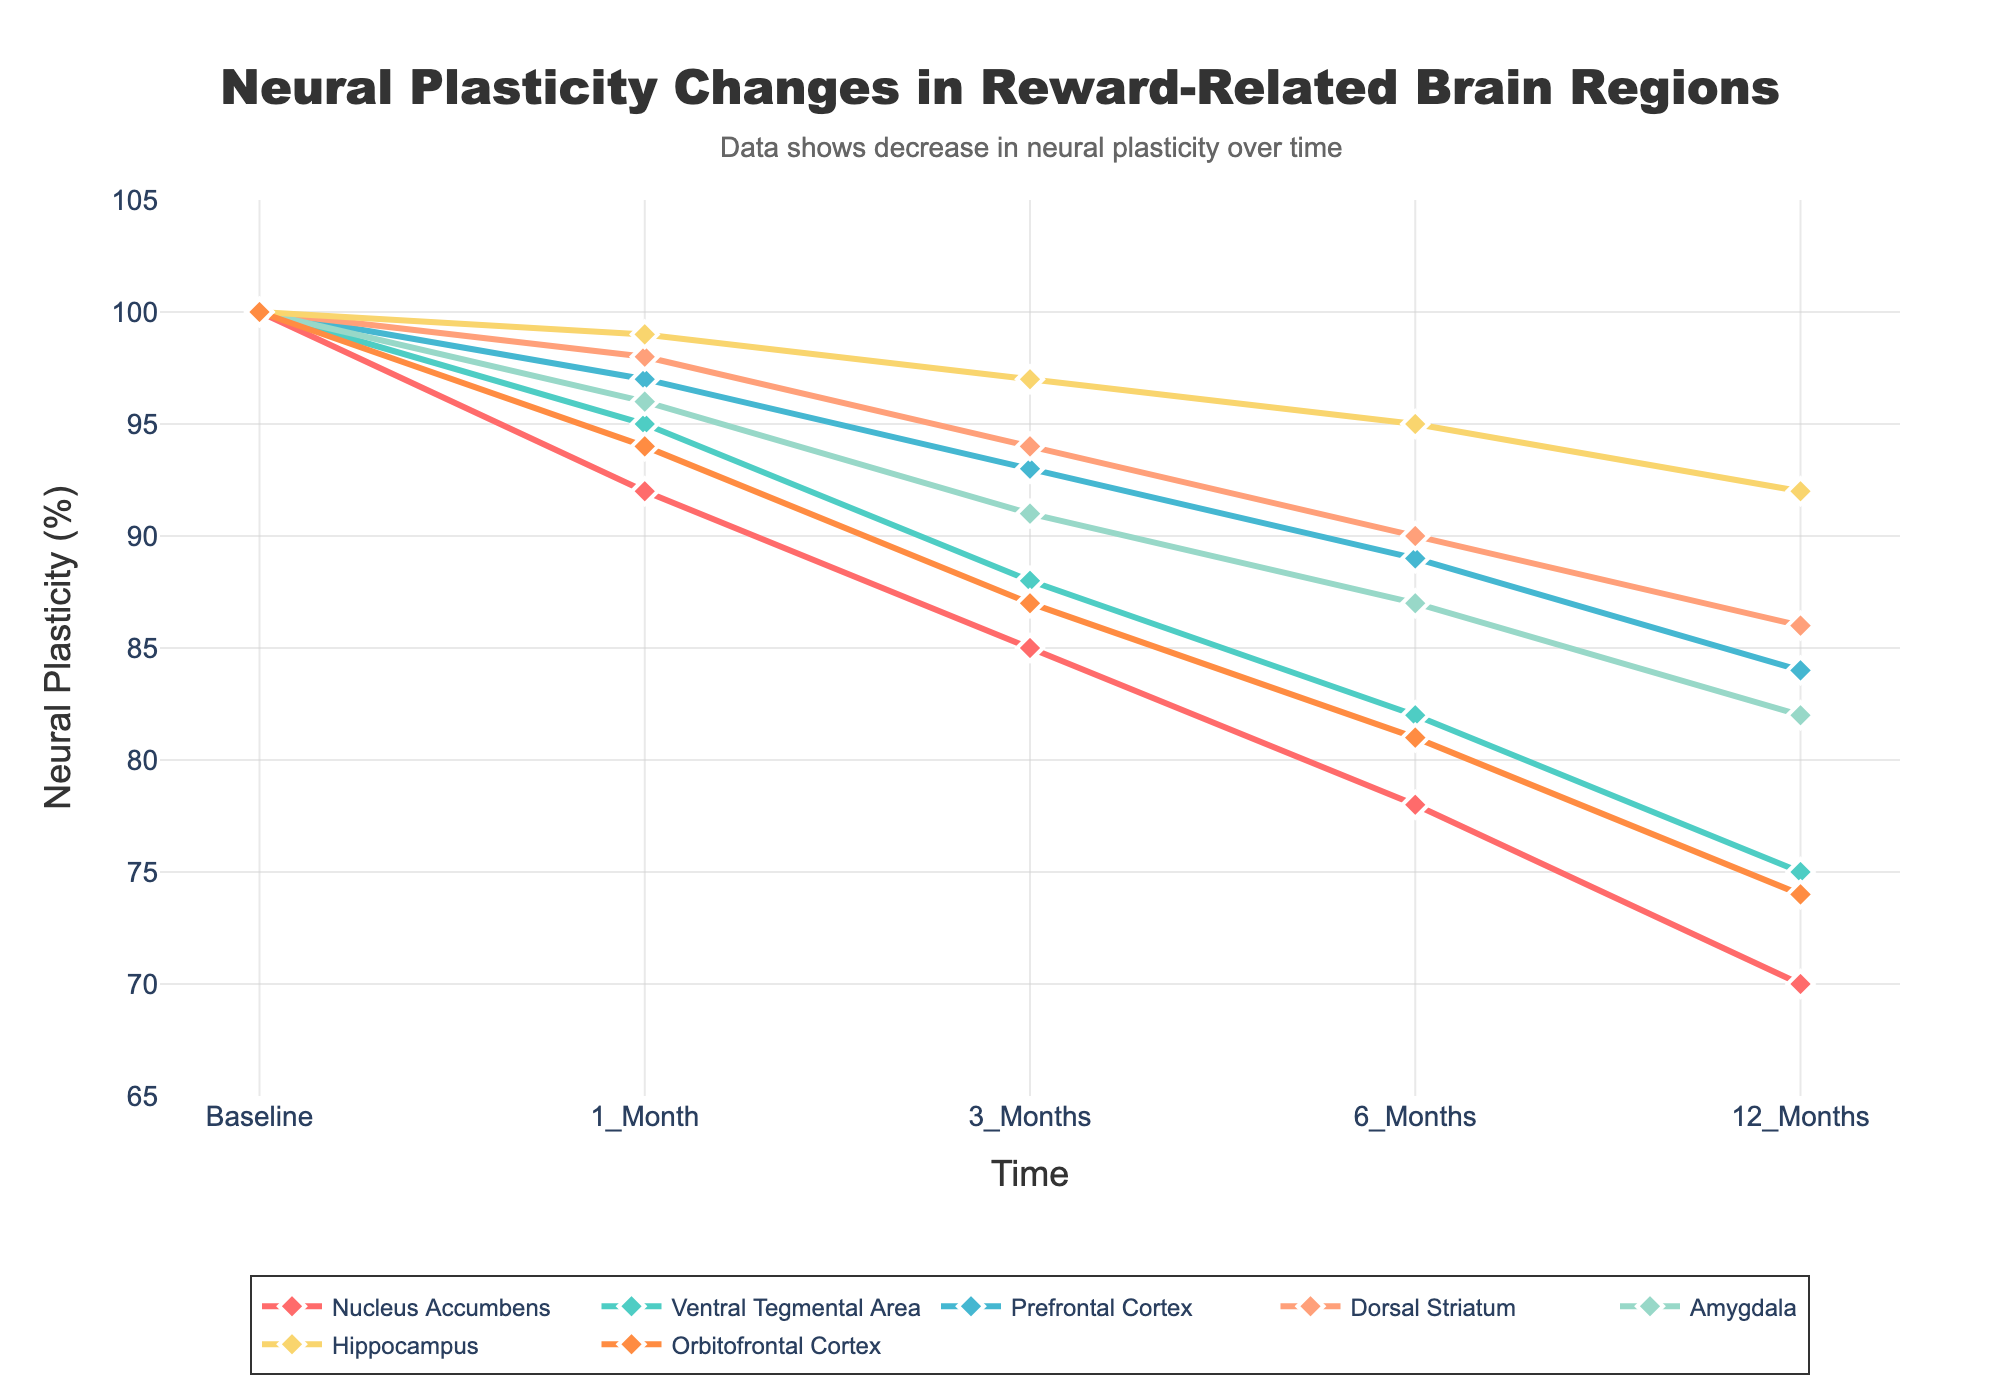Which brain region shows the greatest decrease in neural plasticity after 12 months? First, identify the neural plasticity percentage for each brain region at the 12-month mark. Nucleus Accumbens: 70, Ventral Tegmental Area: 75, Prefrontal Cortex: 84, Dorsal Striatum: 86, Amygdala: 82, Hippocampus: 92, Orbitofrontal Cortex: 74. The Nucleus Accumbens has the lowest value, indicating the greatest decrease.
Answer: Nucleus Accumbens By how much did neural plasticity in the Prefrontal Cortex decrease from baseline to 12 months? The baseline value for the Prefrontal Cortex is 100, and the value at 12 months is 84. The decrease is 100 - 84 = 16.
Answer: 16 Which brain region shows the least change in neural plasticity over the 12-month period? To determine this, compare the differences between baseline and 12 months for all brain regions. Nucleus Accumbens: 30, Ventral Tegmental Area: 25, Prefrontal Cortex: 16, Dorsal Striatum: 14, Amygdala: 18, Hippocampus: 8, Orbitofrontal Cortex: 26. The Hippocampus shows the least change.
Answer: Hippocampus Between 3 and 6 months, which brain region shows the smallest decrease in neural plasticity? Calculate the differences between the 3-month and 6-month values for each brain region. Nucleus Accumbens: 85 - 78 = 7, Ventral Tegmental Area: 88 - 82 = 6, Prefrontal Cortex: 93 - 89 = 4, Dorsal Striatum: 94 - 90 = 4, Amygdala: 91 - 87 = 4, Hippocampus: 97 - 95 = 2, Orbitofrontal Cortex: 87 - 81 = 6. The Hippocampus shows the smallest decrease.
Answer: Hippocampus Which brain regions have similar trajectories over the 12-month period? Visually inspect the lines on the graph to identify those with similar slopes and patterns. The Prefrontal Cortex and Dorsal Striatum, and Amygdala show very similar decline trajectories.
Answer: Prefrontal Cortex and Dorsal Striatum, Amygdala What is the average neural plasticity percentage at 6 months for all brain regions? Sum the values at the 6-month mark for each brain region and divide by the number of regions: (78 + 82 + 89 + 90 + 87 + 95 + 81) / 7 = 602 / 7 ≈ 86.
Answer: 86 How does the neural plasticity percentage change in the Amygdala compare to the Orbitofrontal Cortex from baseline to 12 months? Calculate the difference for both regions: Amygdala: 100 - 82 = 18, Orbitofrontal Cortex: 100 - 74 = 26. The Orbitofrontal Cortex has a greater decrease than the Amygdala.
Answer: Orbitofrontal Cortex has a greater decrease At which time points do the Nucleus Accumbens and Ventral Tegmental Area have the exact same neural plasticity percentage? Compare the values across all time points: Baseline: both 100, 1 Month: Nucleus Accumbens 92, VTA 95; 3 Months: Nucleus Accumbens 85, VTA 88; 6 Months: Nucleus Accumbens 78, VTA 82; 12 Months: Nucleus Accumbens 70, VTA 75. Therefore, they are the same only at baseline.
Answer: Baseline 